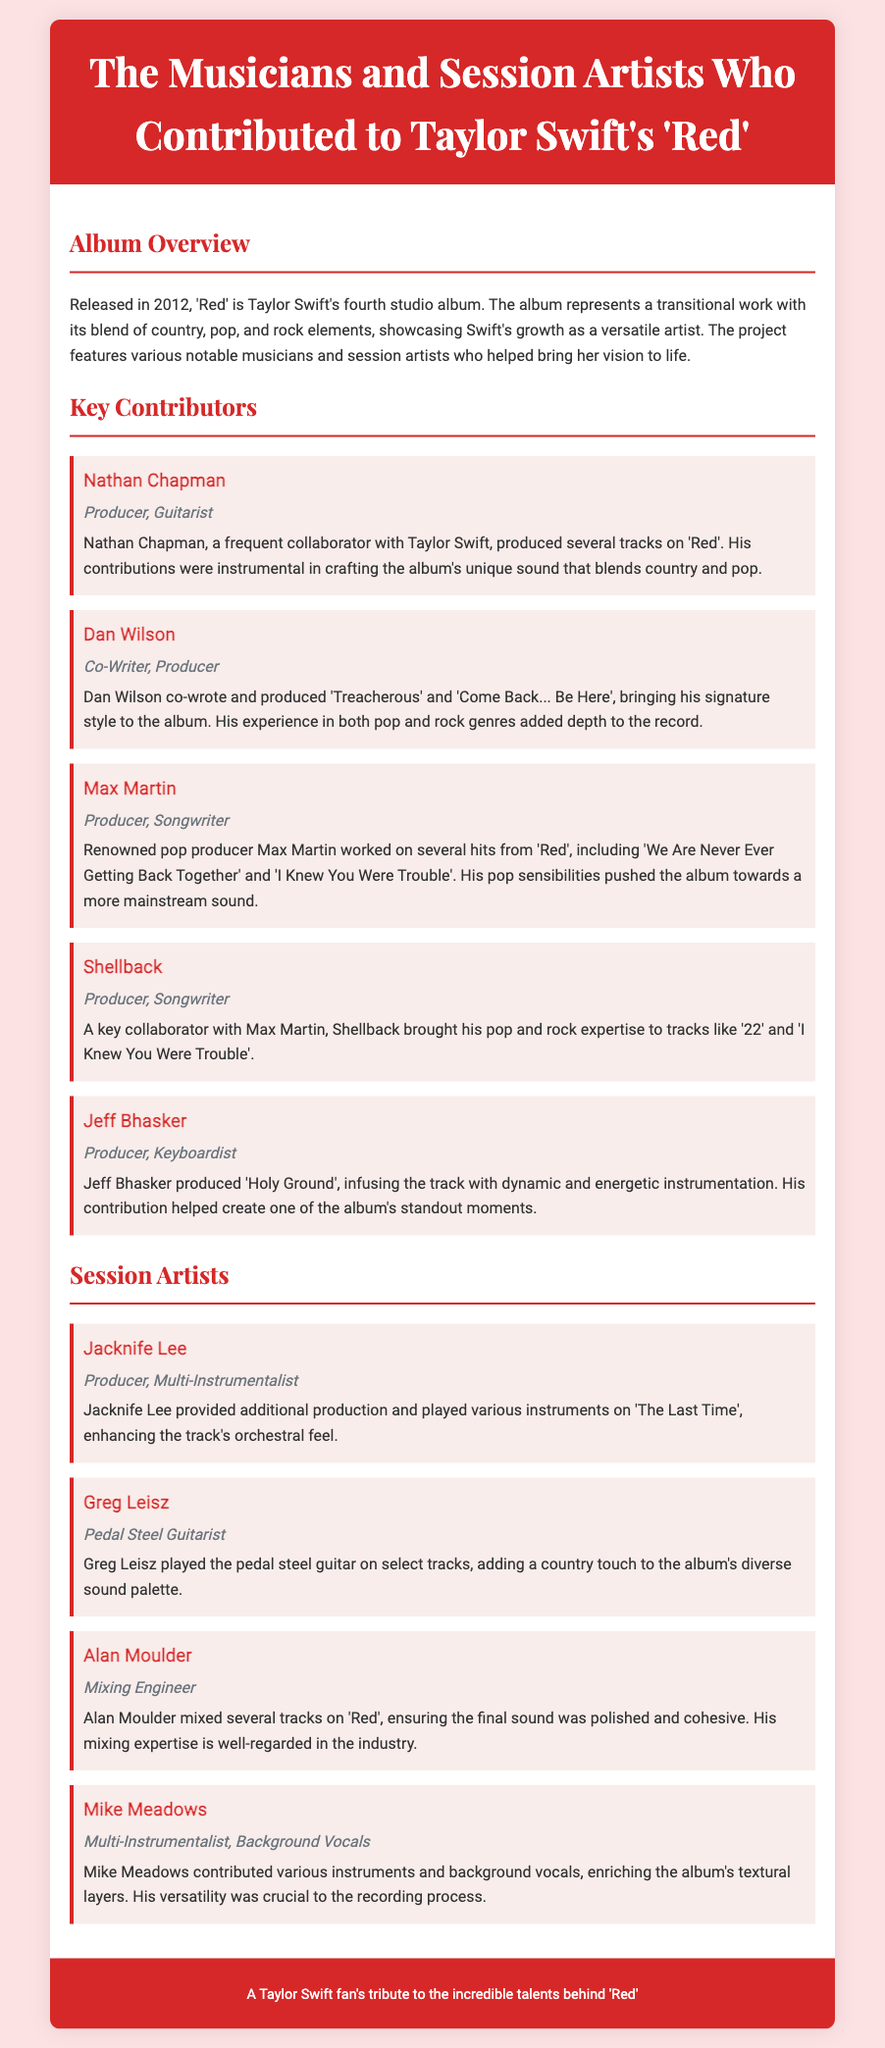What year was the album "Red" released? The album "Red" was released in 2012, as stated in the overview section of the document.
Answer: 2012 Who produced "Holy Ground"? The producer of "Holy Ground" is Jeff Bhasker, as mentioned under the Key Contributors section.
Answer: Jeff Bhasker Which song did Nathan Chapman collaborate on? Nathan Chapman produced several tracks, indicating his collaboration but does not specify a single song; however, it implies he worked on "Red".
Answer: Various tracks What role did Max Martin have in the album "Red"? Max Martin's role in the album includes being a producer and songwriter, as highlighted under Key Contributors.
Answer: Producer, Songwriter How many session artists are mentioned in the document? The document lists four session artists in the Session Artists section.
Answer: Four What is Greg Leisz's contribution to the album? Greg Leisz played the pedal steel guitar, adding to the album's diverse sound palette as stated in the description of his role.
Answer: Pedal Steel Guitarist Which song features contributions from both Shellback and Max Martin? The song "I Knew You Were Trouble" features contributions from both Shellback and Max Martin, implying a collaboration.
Answer: "I Knew You Were Trouble" What type of document is this? The document is structured as a Playbill, presenting information about the contributors to an album, which is a typical format for showcasing talent in a theatre or musical context.
Answer: Playbill 